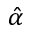Convert formula to latex. <formula><loc_0><loc_0><loc_500><loc_500>\hat { \alpha }</formula> 